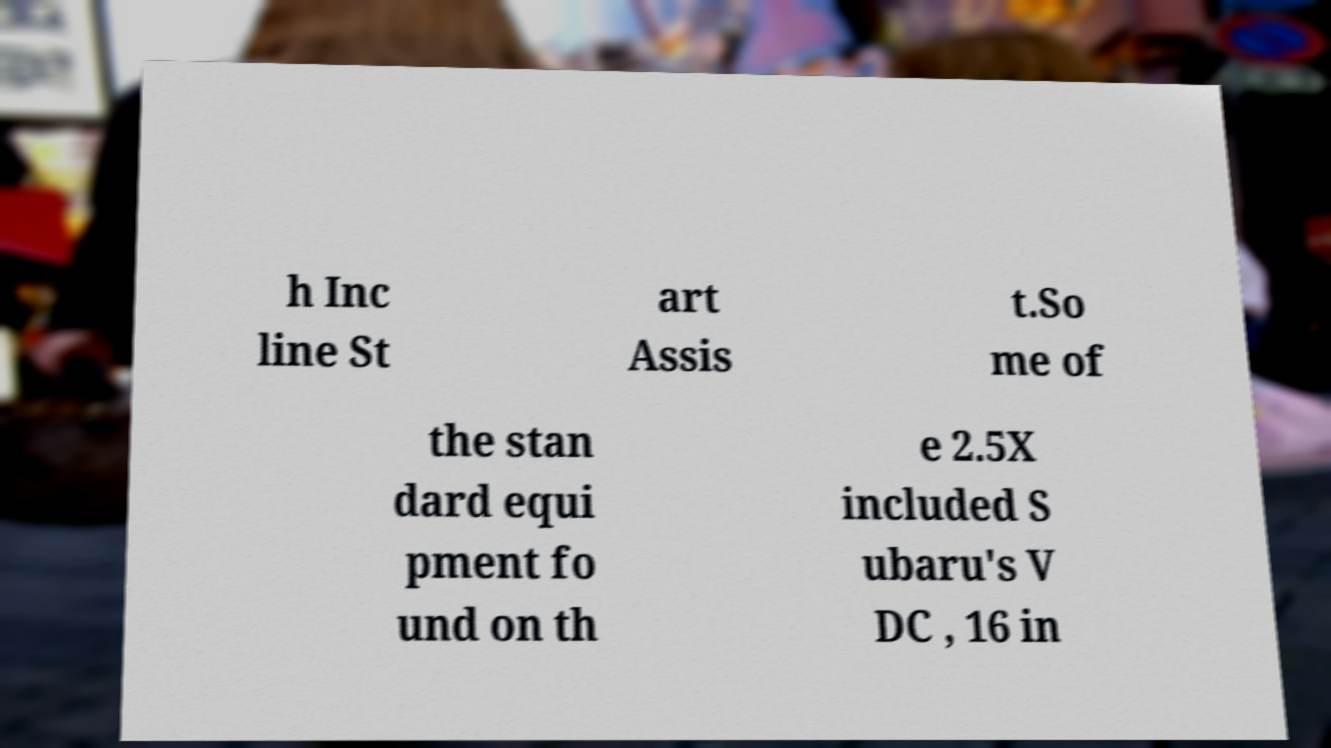Can you accurately transcribe the text from the provided image for me? h Inc line St art Assis t.So me of the stan dard equi pment fo und on th e 2.5X included S ubaru's V DC , 16 in 